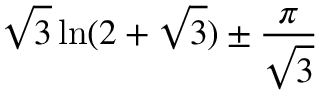<formula> <loc_0><loc_0><loc_500><loc_500>{ \sqrt { 3 } } \ln ( 2 + { \sqrt { 3 } } ) \pm { \frac { \pi } { \sqrt { 3 } } }</formula> 